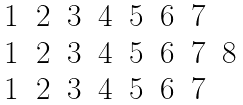<formula> <loc_0><loc_0><loc_500><loc_500>\begin{matrix} 1 & 2 & 3 & 4 & 5 & 6 & 7 & \\ 1 & 2 & 3 & 4 & 5 & 6 & 7 & 8 \\ 1 & 2 & 3 & 4 & 5 & 6 & 7 & \end{matrix}</formula> 